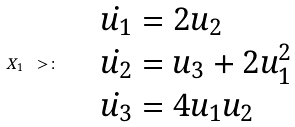<formula> <loc_0><loc_0><loc_500><loc_500>X _ { 1 } \ > \colon \quad \begin{array} { l } \dot { u _ { 1 } } = 2 u _ { 2 } \\ \dot { u _ { 2 } } = u _ { 3 } + 2 u _ { 1 } ^ { 2 } \\ \dot { u _ { 3 } } = 4 u _ { 1 } u _ { 2 } \end{array}</formula> 